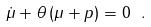<formula> <loc_0><loc_0><loc_500><loc_500>\dot { \mu } + \theta \, ( \mu + p ) = 0 \ .</formula> 